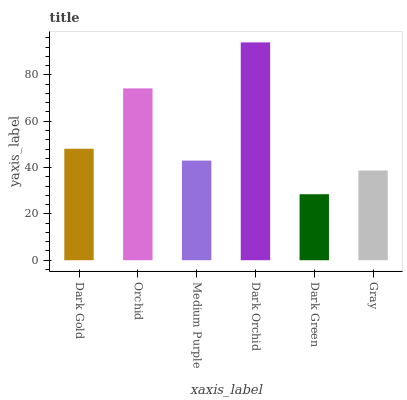Is Dark Green the minimum?
Answer yes or no. Yes. Is Dark Orchid the maximum?
Answer yes or no. Yes. Is Orchid the minimum?
Answer yes or no. No. Is Orchid the maximum?
Answer yes or no. No. Is Orchid greater than Dark Gold?
Answer yes or no. Yes. Is Dark Gold less than Orchid?
Answer yes or no. Yes. Is Dark Gold greater than Orchid?
Answer yes or no. No. Is Orchid less than Dark Gold?
Answer yes or no. No. Is Dark Gold the high median?
Answer yes or no. Yes. Is Medium Purple the low median?
Answer yes or no. Yes. Is Gray the high median?
Answer yes or no. No. Is Dark Gold the low median?
Answer yes or no. No. 